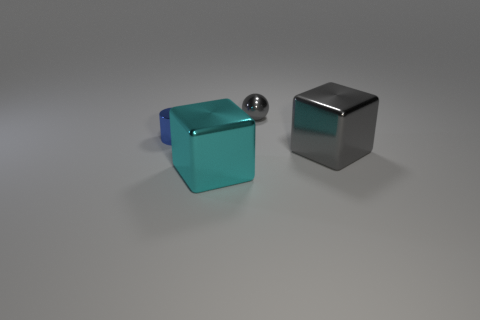The big cyan object is what shape?
Give a very brief answer. Cube. What is the size of the object that is the same color as the tiny metallic ball?
Offer a very short reply. Large. What color is the shiny cylinder?
Your response must be concise. Blue. What is the color of the thing that is both to the right of the cyan metal object and in front of the gray shiny ball?
Your answer should be compact. Gray. The cube to the left of the gray shiny thing that is in front of the small metallic thing that is on the right side of the small blue cylinder is what color?
Provide a succinct answer. Cyan. The shiny cylinder that is the same size as the gray shiny sphere is what color?
Your answer should be very brief. Blue. There is a tiny object that is left of the big metallic block left of the big shiny object on the right side of the cyan metallic thing; what shape is it?
Offer a terse response. Cylinder. The big metal thing that is the same color as the tiny ball is what shape?
Keep it short and to the point. Cube. What number of objects are large red cylinders or things that are to the left of the tiny shiny sphere?
Offer a terse response. 2. Do the metal block that is right of the metal ball and the small gray thing have the same size?
Offer a very short reply. No. 